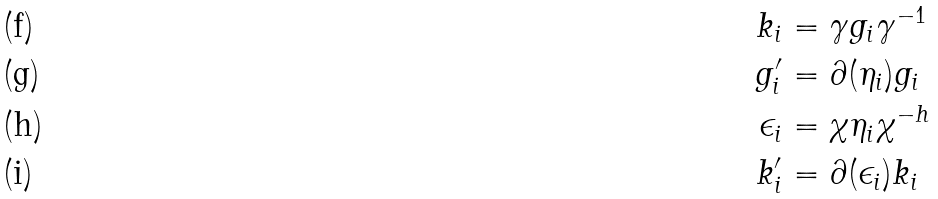Convert formula to latex. <formula><loc_0><loc_0><loc_500><loc_500>k _ { i } & = \gamma g _ { i } \gamma ^ { - 1 } \\ g ^ { \prime } _ { i } & = \partial ( \eta _ { i } ) g _ { i } \\ \epsilon _ { i } & = \chi \eta _ { i } \chi ^ { - h } \\ k ^ { \prime } _ { i } & = \partial ( \epsilon _ { i } ) k _ { i }</formula> 